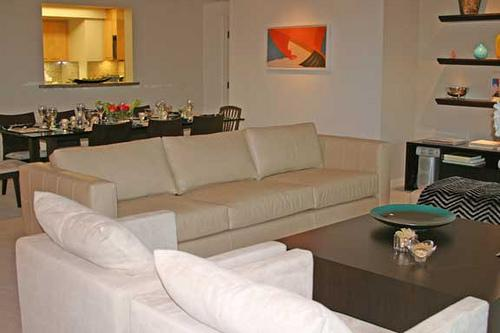Question: what is brown?
Choices:
A. The boys hair.
B. The pile of wood.
C. Coffee table.
D. The pencil.
Answer with the letter. Answer: C Question: where is a blue vase?
Choices:
A. On the window sill.
B. On a shelf.
C. On the back of the toilet.
D. On the table.
Answer with the letter. Answer: B Question: what is white?
Choices:
A. The couch.
B. The dog.
C. The sand.
D. The ball.
Answer with the letter. Answer: A Question: where are chairs?
Choices:
A. At the dining table.
B. On the porch.
C. At the desk.
D. In the living room.
Answer with the letter. Answer: A 